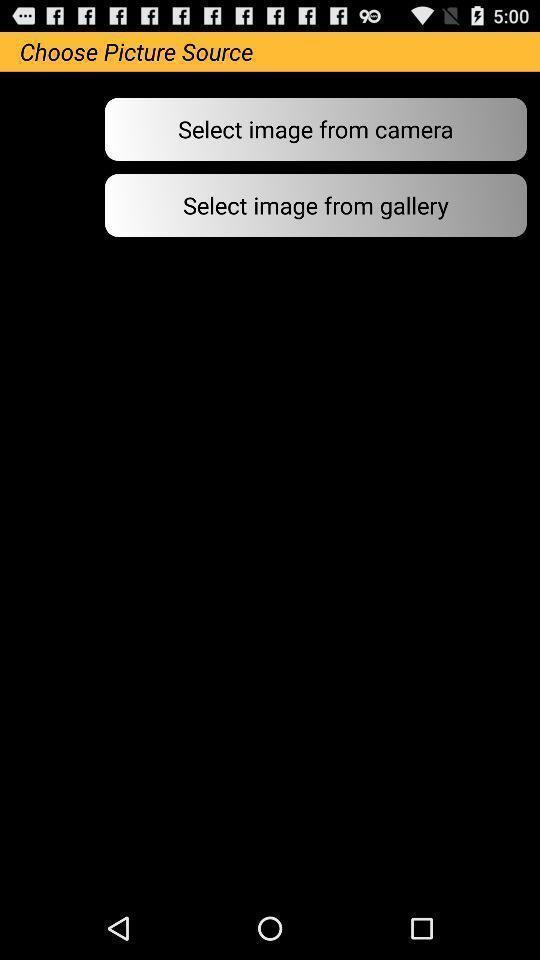What is the overall content of this screenshot? Page to choose a picture source. 